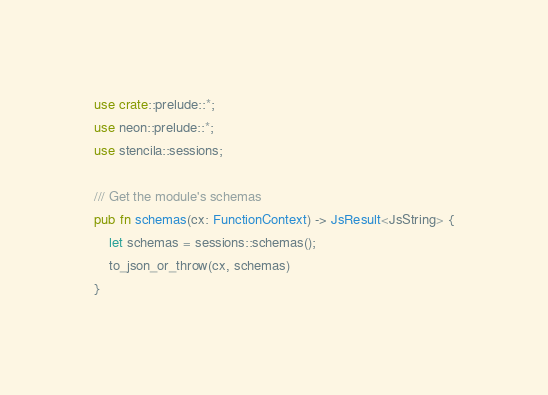Convert code to text. <code><loc_0><loc_0><loc_500><loc_500><_Rust_>use crate::prelude::*;
use neon::prelude::*;
use stencila::sessions;

/// Get the module's schemas
pub fn schemas(cx: FunctionContext) -> JsResult<JsString> {
    let schemas = sessions::schemas();
    to_json_or_throw(cx, schemas)
}
</code> 